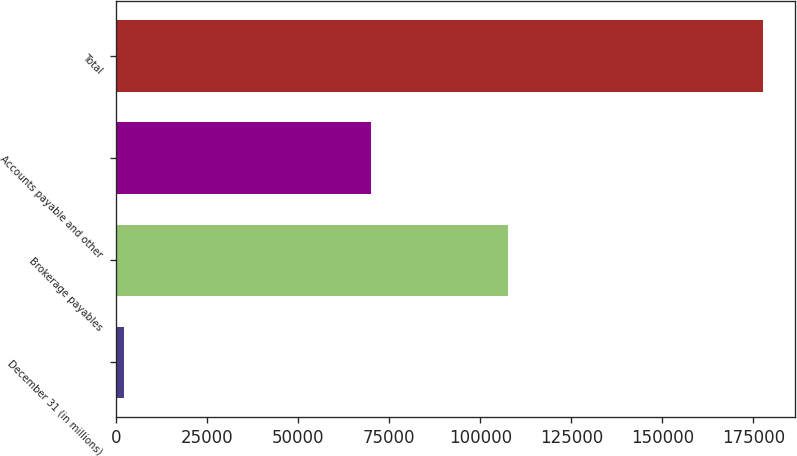Convert chart. <chart><loc_0><loc_0><loc_500><loc_500><bar_chart><fcel>December 31 (in millions)<fcel>Brokerage payables<fcel>Accounts payable and other<fcel>Total<nl><fcel>2015<fcel>107632<fcel>70006<fcel>177638<nl></chart> 